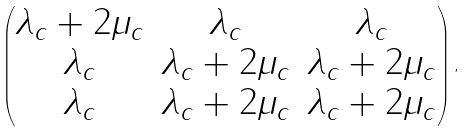<formula> <loc_0><loc_0><loc_500><loc_500>\begin{pmatrix} \lambda _ { c } + 2 \mu _ { c } & \lambda _ { c } & \lambda _ { c } \\ \lambda _ { c } & \lambda _ { c } + 2 \mu _ { c } & \lambda _ { c } + 2 \mu _ { c } \\ \lambda _ { c } & \lambda _ { c } + 2 \mu _ { c } & \lambda _ { c } + 2 \mu _ { c } \end{pmatrix} ,</formula> 